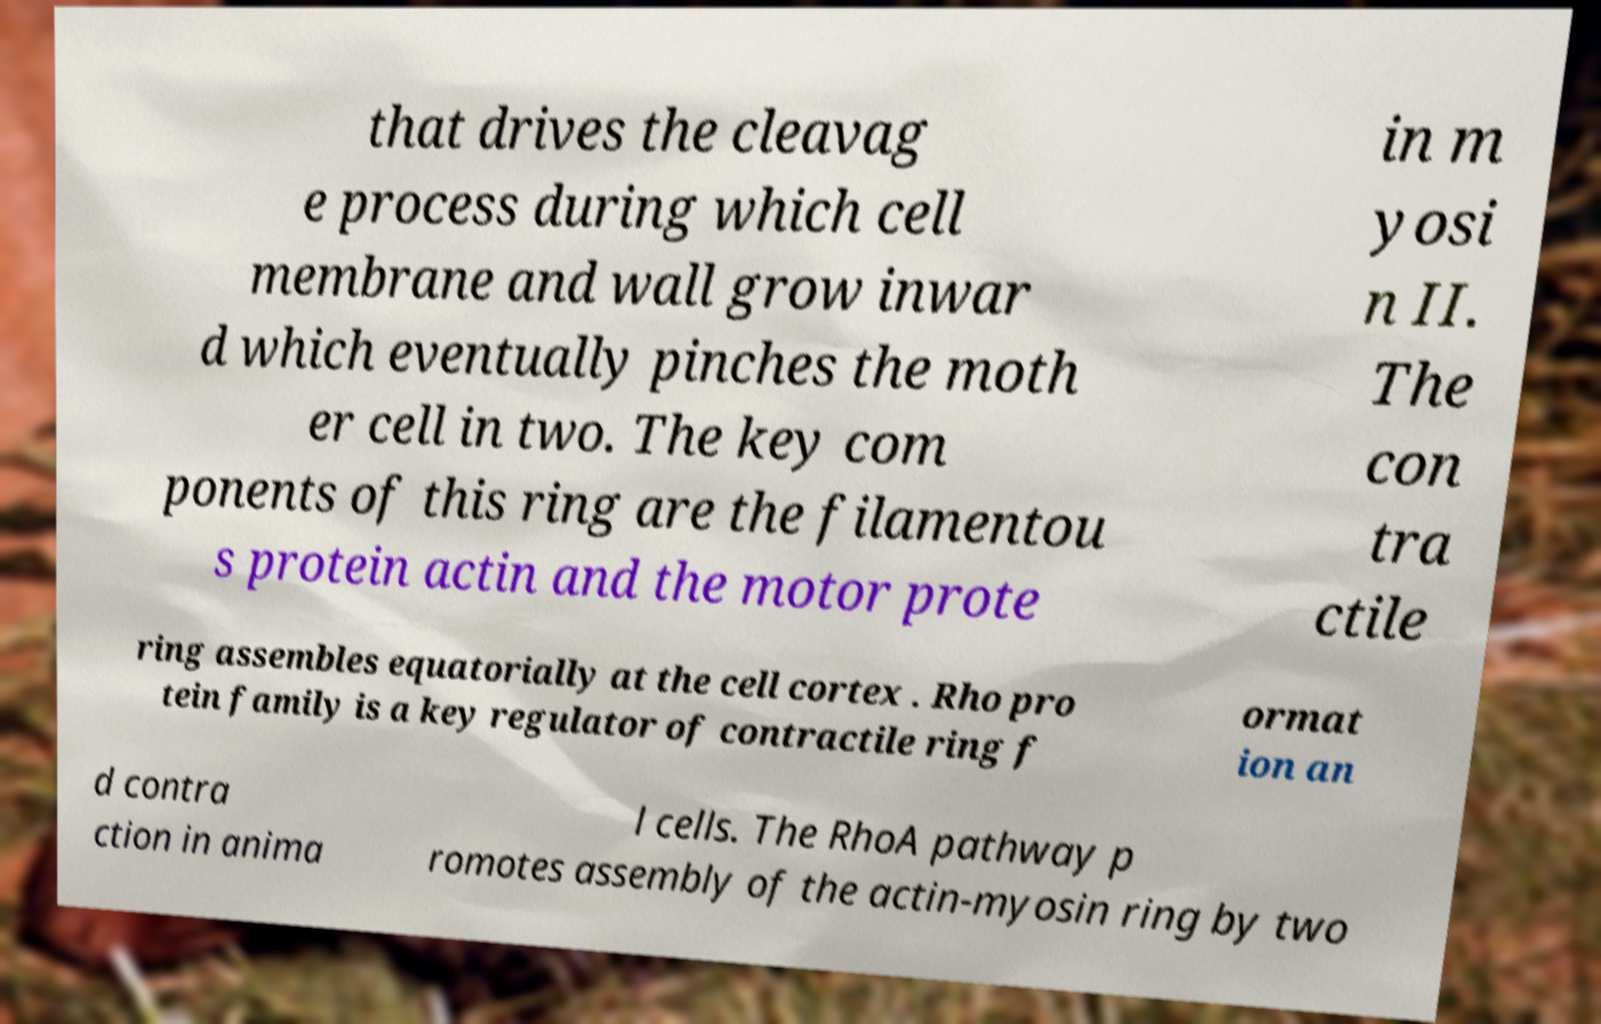Can you accurately transcribe the text from the provided image for me? that drives the cleavag e process during which cell membrane and wall grow inwar d which eventually pinches the moth er cell in two. The key com ponents of this ring are the filamentou s protein actin and the motor prote in m yosi n II. The con tra ctile ring assembles equatorially at the cell cortex . Rho pro tein family is a key regulator of contractile ring f ormat ion an d contra ction in anima l cells. The RhoA pathway p romotes assembly of the actin-myosin ring by two 